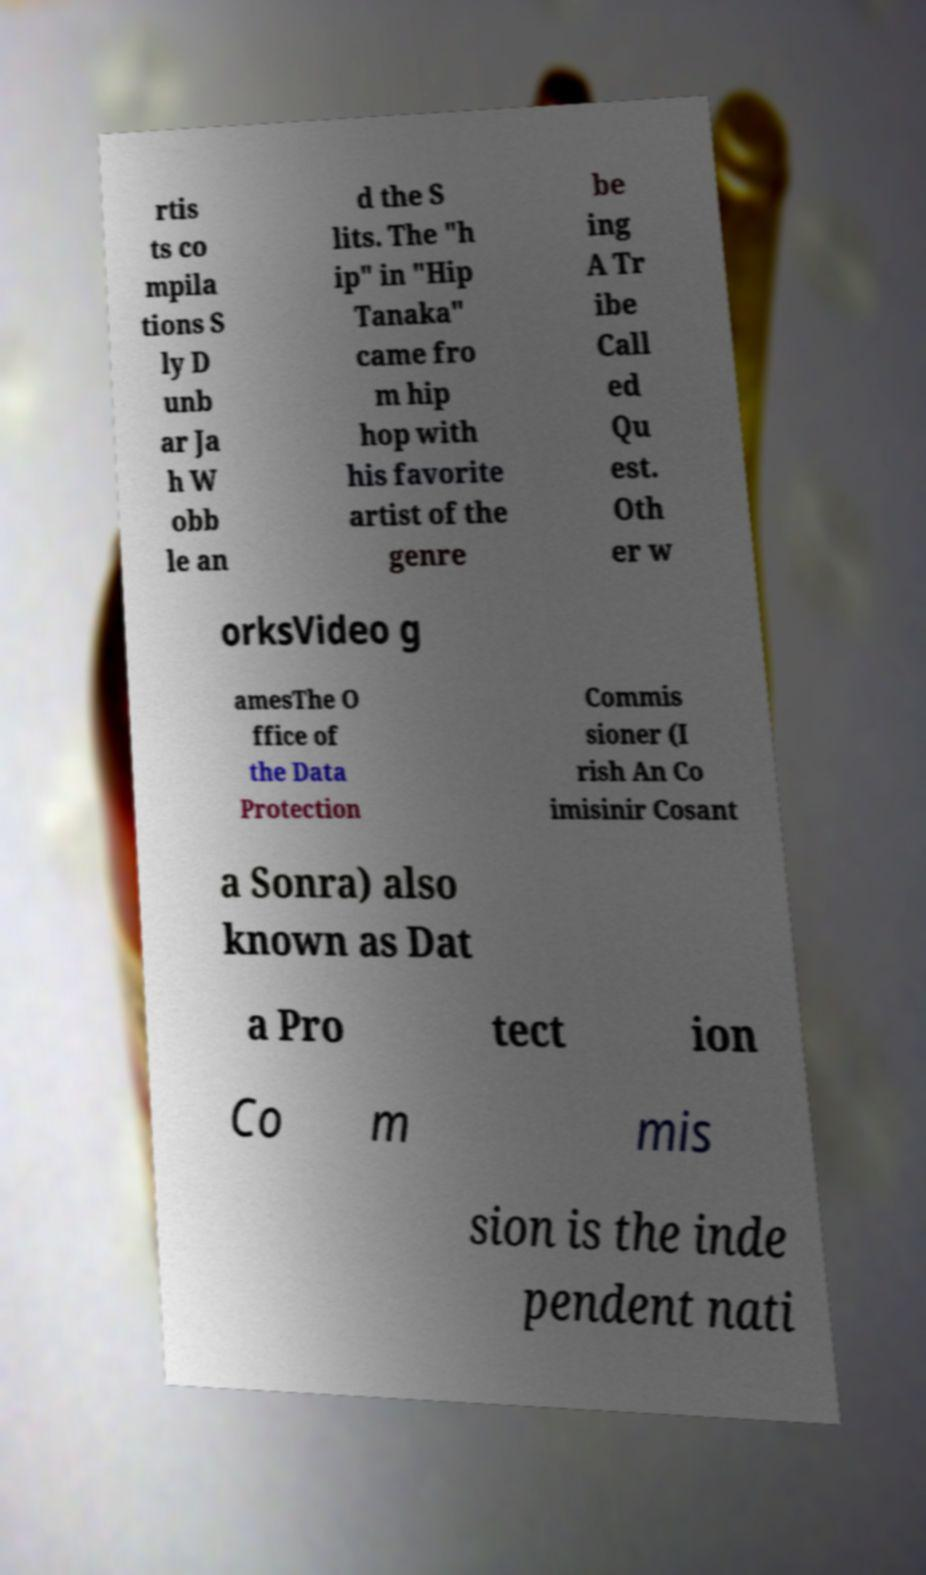What messages or text are displayed in this image? I need them in a readable, typed format. rtis ts co mpila tions S ly D unb ar Ja h W obb le an d the S lits. The "h ip" in "Hip Tanaka" came fro m hip hop with his favorite artist of the genre be ing A Tr ibe Call ed Qu est. Oth er w orksVideo g amesThe O ffice of the Data Protection Commis sioner (I rish An Co imisinir Cosant a Sonra) also known as Dat a Pro tect ion Co m mis sion is the inde pendent nati 